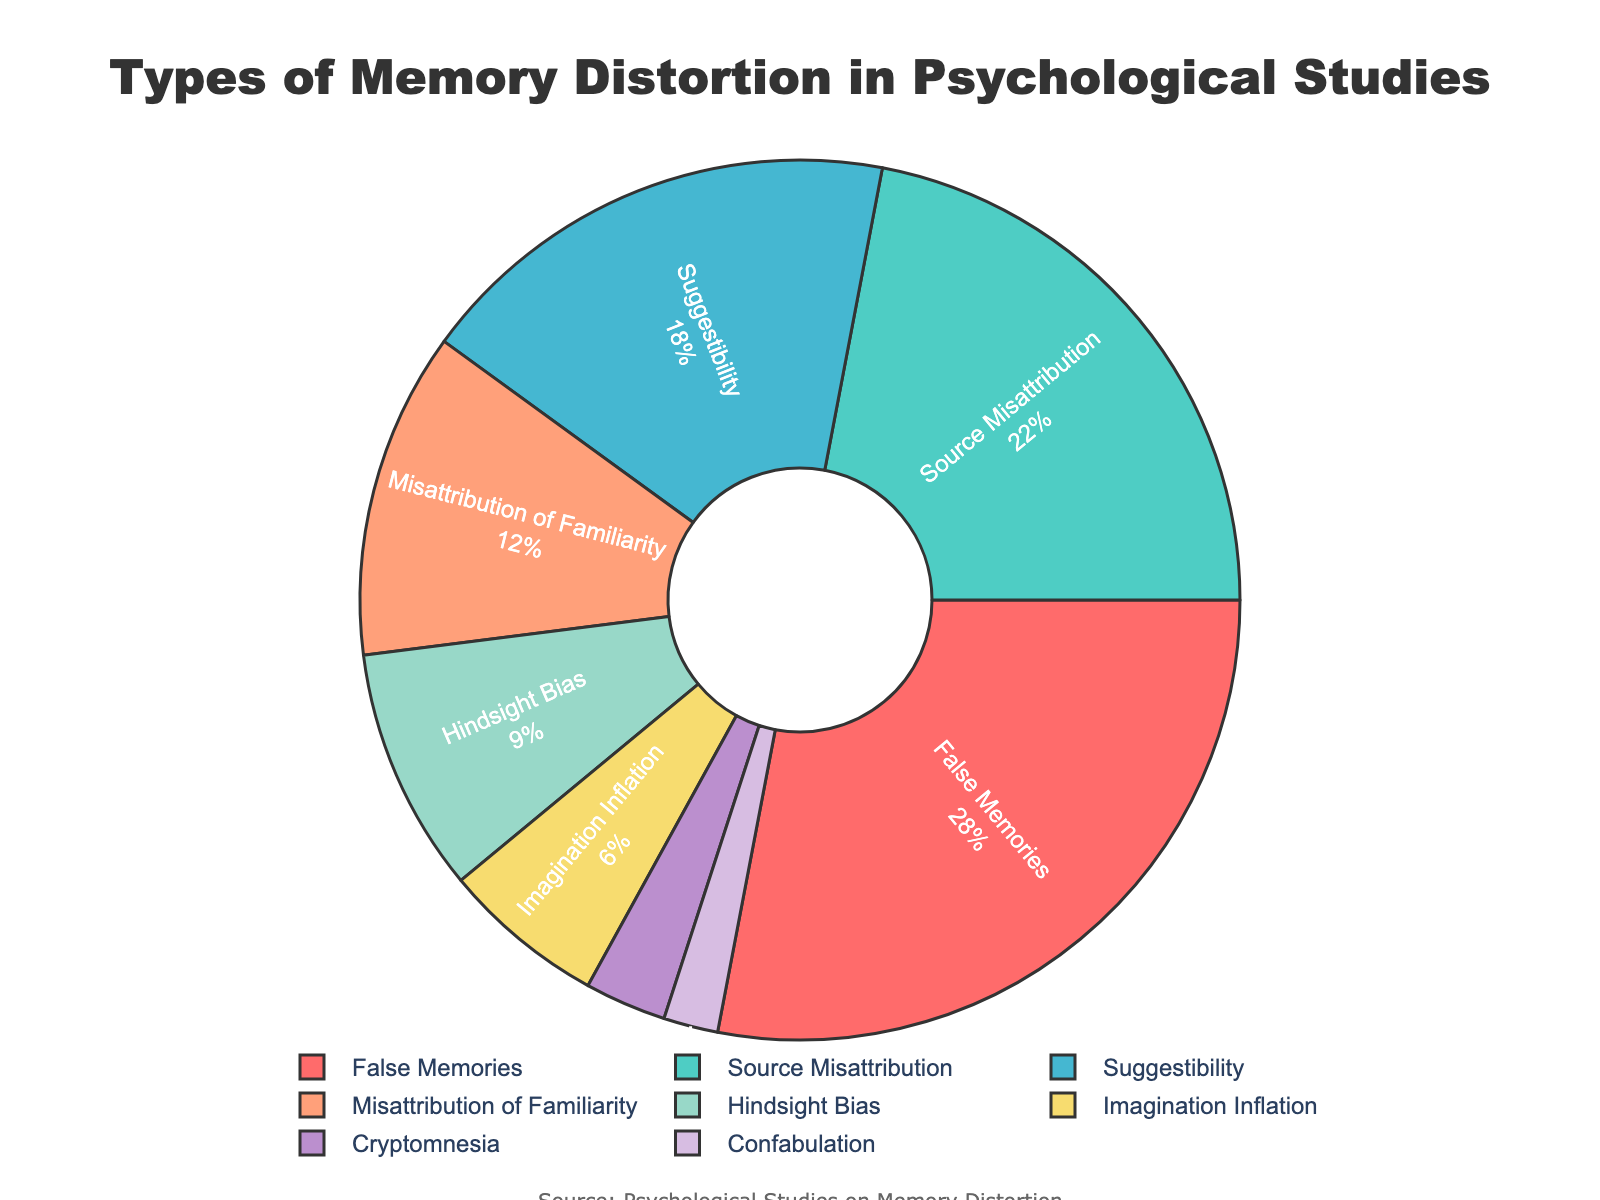Which type of memory distortion is the most frequently reported? The pie chart shows the percentage of different types of memory distortion. The largest section of the pie chart, labeled "False Memories," accounts for 28%.
Answer: False Memories What is the sum of the percentages for Source Misattribution and Suggestibility? To find the sum, add the percentages of Source Misattribution (22%) and Suggestibility (18%): 22 + 18 = 40.
Answer: 40% Which type of memory distortion has a lower percentage, Imagination Inflation or Cryptomnesia? The pie chart indicates that Imagination Inflation has 6%, while Cryptomnesia has 3%. Comparing these values, Cryptomnesia has a lower percentage.
Answer: Cryptomnesia How much larger is the percentage of Misattribution of Familiarity compared to Confabulation? Subtract the percentage of Confabulation (2%) from Misattribution of Familiarity (12%): 12 - 2 = 10.
Answer: 10% What is the combined percentage of all memory distortions except for False Memories? Subtract the percentage of False Memories (28%) from 100% to find the combined percentage of the others: 100 - 28 = 72.
Answer: 72% Which memory distortion type is represented in blue on the pie chart? The pie chart shows Source Misattribution represented in blue, as indicated by the color coding.
Answer: Source Misattribution What is the difference in percentage between the most and the least frequently reported memory distortions? Subtract the percentage of the least frequently reported type (Confabulation, 2%) from the most frequently reported type (False Memories, 28%): 28 - 2 = 26.
Answer: 26% List all memory distortion types having a percentage lower than 10%. The pie chart shows that Hindsight Bias (9%), Imagination Inflation (6%), Cryptomnesia (3%), and Confabulation (2%) all have percentages lower than 10%.
Answer: Hindsight Bias, Imagination Inflation, Cryptomnesia, Confabulation 